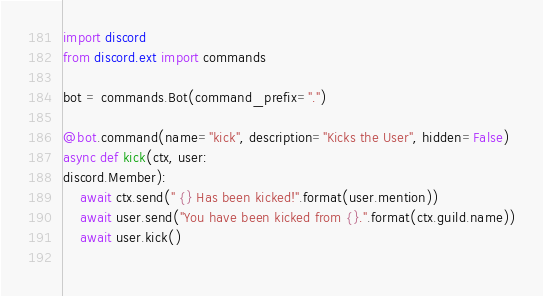Convert code to text. <code><loc_0><loc_0><loc_500><loc_500><_Python_>import discord
from discord.ext import commands

bot = commands.Bot(command_prefix=".")

@bot.command(name="kick", description="Kicks the User", hidden=False)
async def kick(ctx, user:
discord.Member):
    await ctx.send(" {} Has been kicked!".format(user.mention))
    await user.send("You have been kicked from {}.".format(ctx.guild.name))
    await user.kick()
    
</code> 